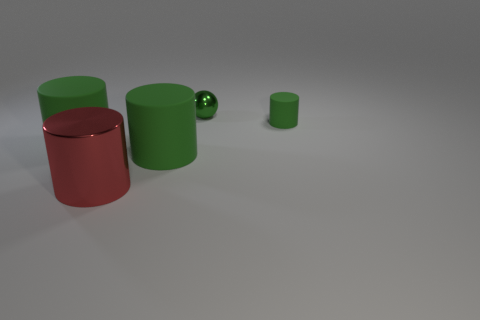Is there any other thing that is the same color as the metallic cylinder? Upon reviewing the contents of the image, it appears that the prior response may have overlooked some details. When comparing the objects in the image, it is noticeable that there are multiple cylinders, some of which share the same color. Specifically, there is a smaller green cylinder that matches the color of the larger green one. Such nuances highlight the importance of closely examining all elements within a visual scene. 